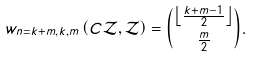Convert formula to latex. <formula><loc_0><loc_0><loc_500><loc_500>w _ { n = k + m , k , m } \left ( C \mathcal { Z } , \mathcal { Z } \right ) = { \left \lfloor \frac { k + m - 1 } { 2 } \right \rfloor \choose \frac { m } { 2 } } .</formula> 